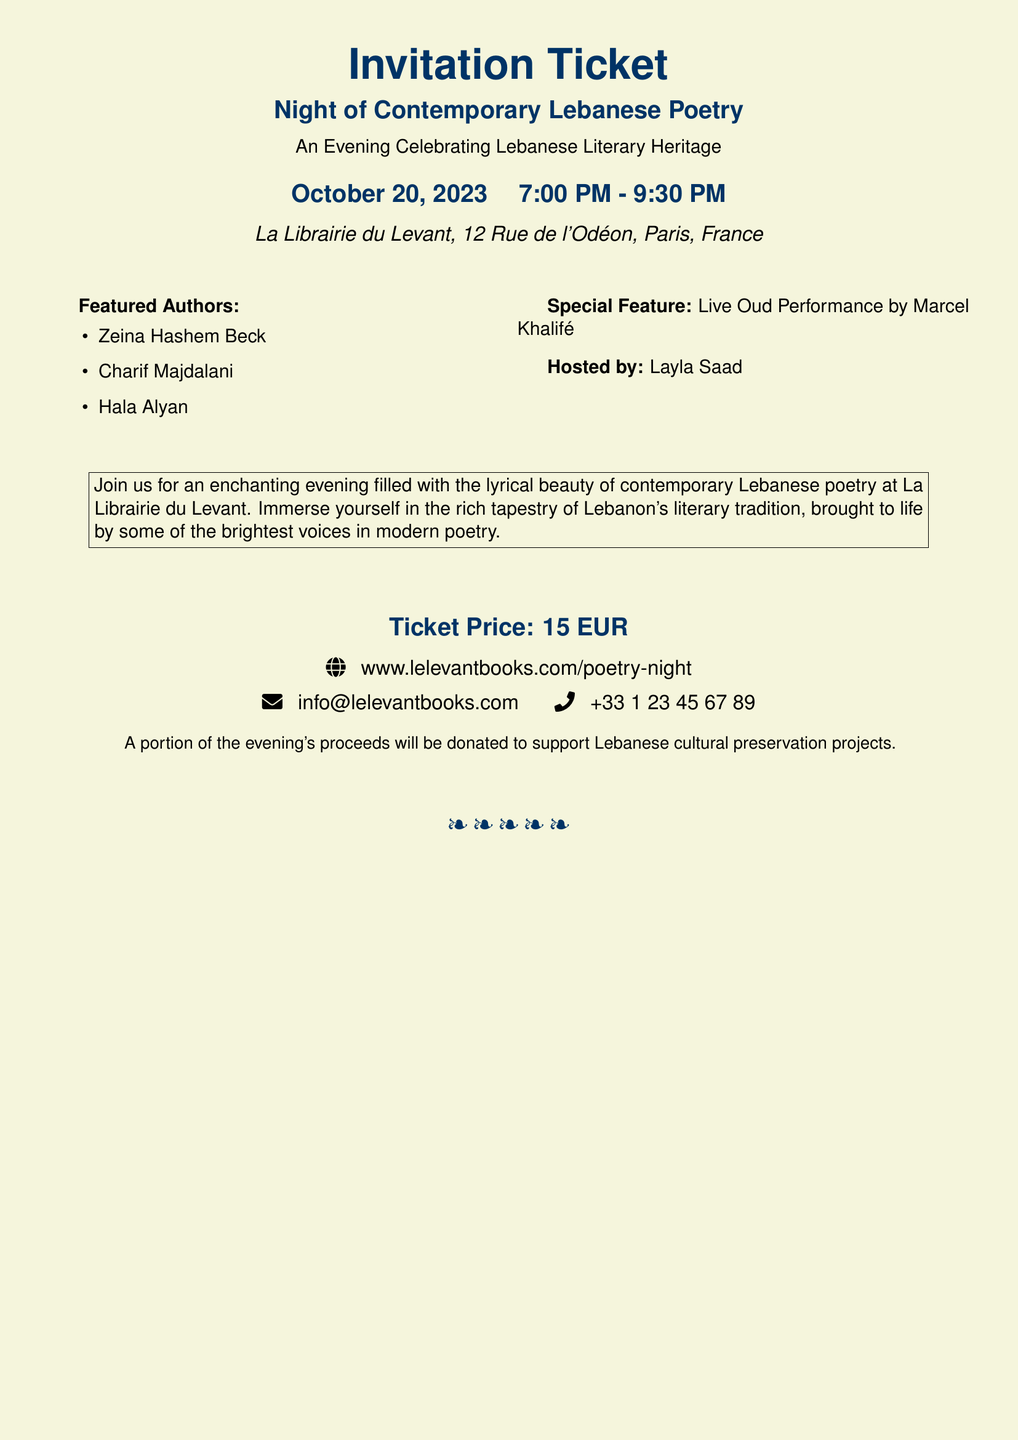What is the event title? The event title is explicitly stated as part of the header in the document.
Answer: Night of Contemporary Lebanese Poetry Who are the featured authors? The document lists the featured authors in a bullet point format.
Answer: Zeina Hashem Beck, Charif Majdalani, Hala Alyan What time does the event start? The starting time of the event is mentioned in the date and time section of the document.
Answer: 7:00 PM Where is the event taking place? The location is clearly provided in the venue section of the ticket information.
Answer: La Librairie du Levant, 12 Rue de l'Odéon, Paris, France What is the ticket price? The ticket price is explicitly mentioned in the pricing section of the document.
Answer: 15 EUR Who is hosting the event? The host is named in the special features section of the document.
Answer: Layla Saad What is the special feature of the evening? The document includes a specific mention of the additional attraction occurring during the event.
Answer: Live Oud Performance by Marcel Khalifé What is the purpose of part of the proceeds? The document states a specific purpose for a portion of the proceeds from the event.
Answer: Support Lebanese cultural preservation projects 